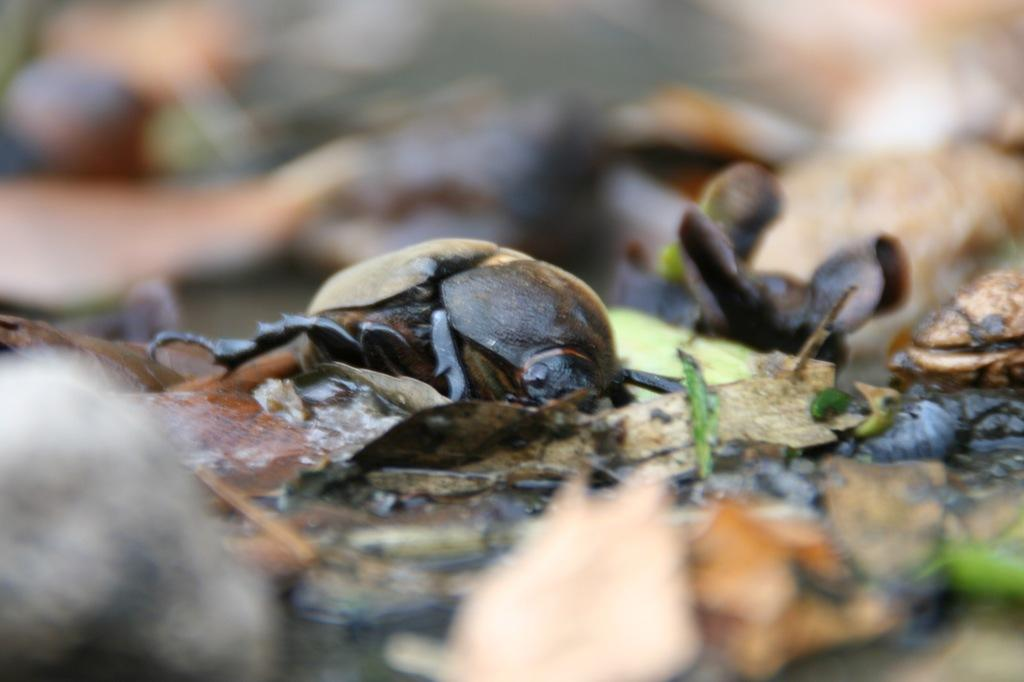What type of creature can be seen in the image? There is an insect in the image. What is the insect's environment in the image? The insect is on dried leaves and grass. Is there any part of the image that is not clear? Some part of the image is blurred. How many brothers does the rabbit in the image have? There is no rabbit present in the image, only an insect. How many cows are visible in the image? There are no cows visible in the image, only an insect on dried leaves and grass. 